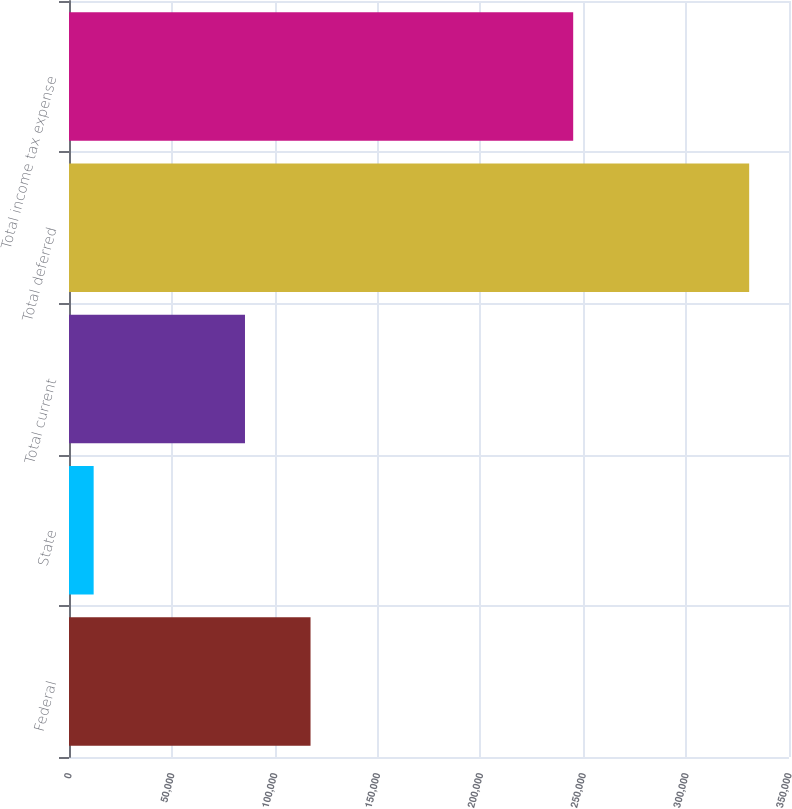<chart> <loc_0><loc_0><loc_500><loc_500><bar_chart><fcel>Federal<fcel>State<fcel>Total current<fcel>Total deferred<fcel>Total income tax expense<nl><fcel>117414<fcel>11983<fcel>85548<fcel>330643<fcel>245095<nl></chart> 